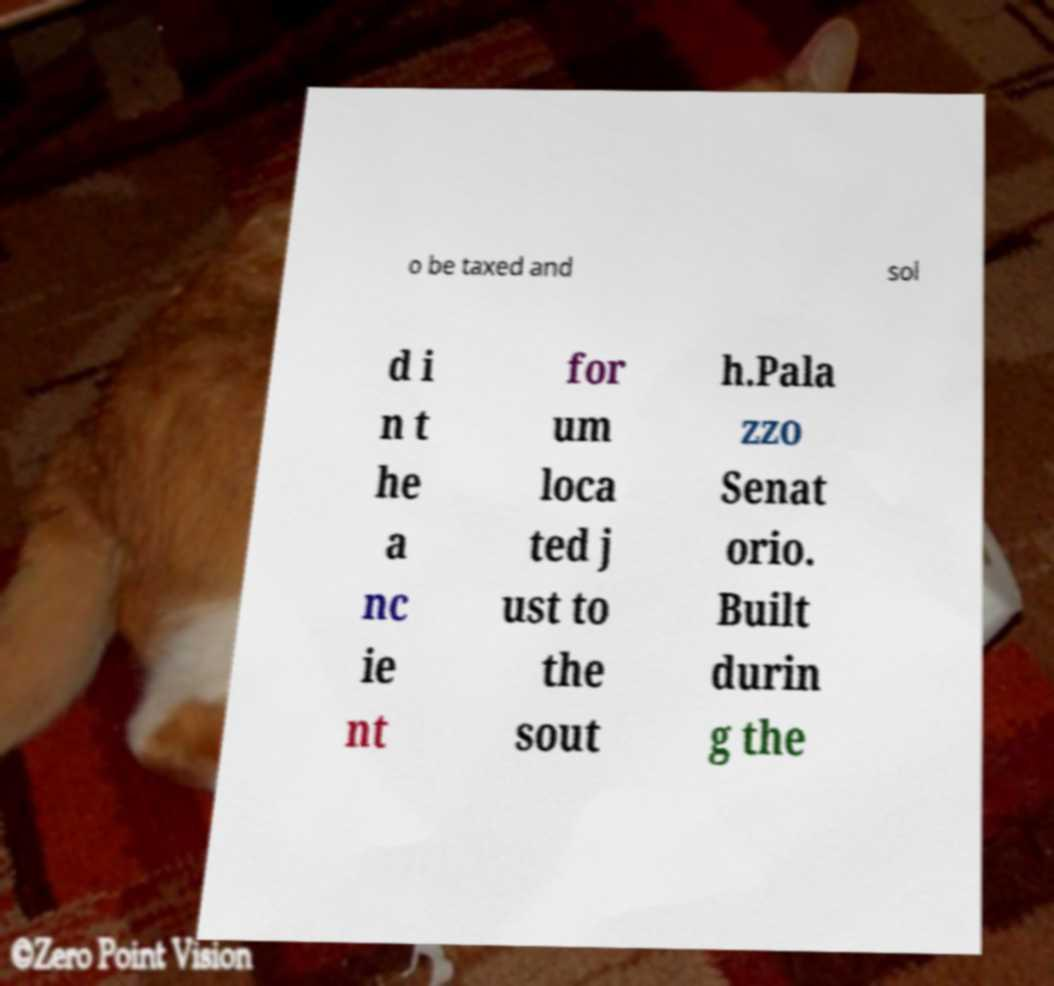There's text embedded in this image that I need extracted. Can you transcribe it verbatim? o be taxed and sol d i n t he a nc ie nt for um loca ted j ust to the sout h.Pala zzo Senat orio. Built durin g the 